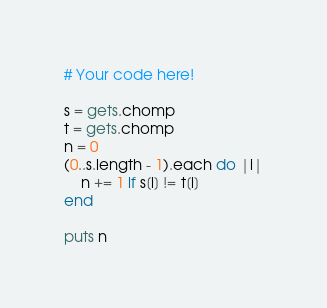<code> <loc_0><loc_0><loc_500><loc_500><_Ruby_># Your code here!

s = gets.chomp 
t = gets.chomp
n = 0
(0..s.length - 1).each do |i|
    n += 1 if s[i] != t[i]
end

puts n</code> 